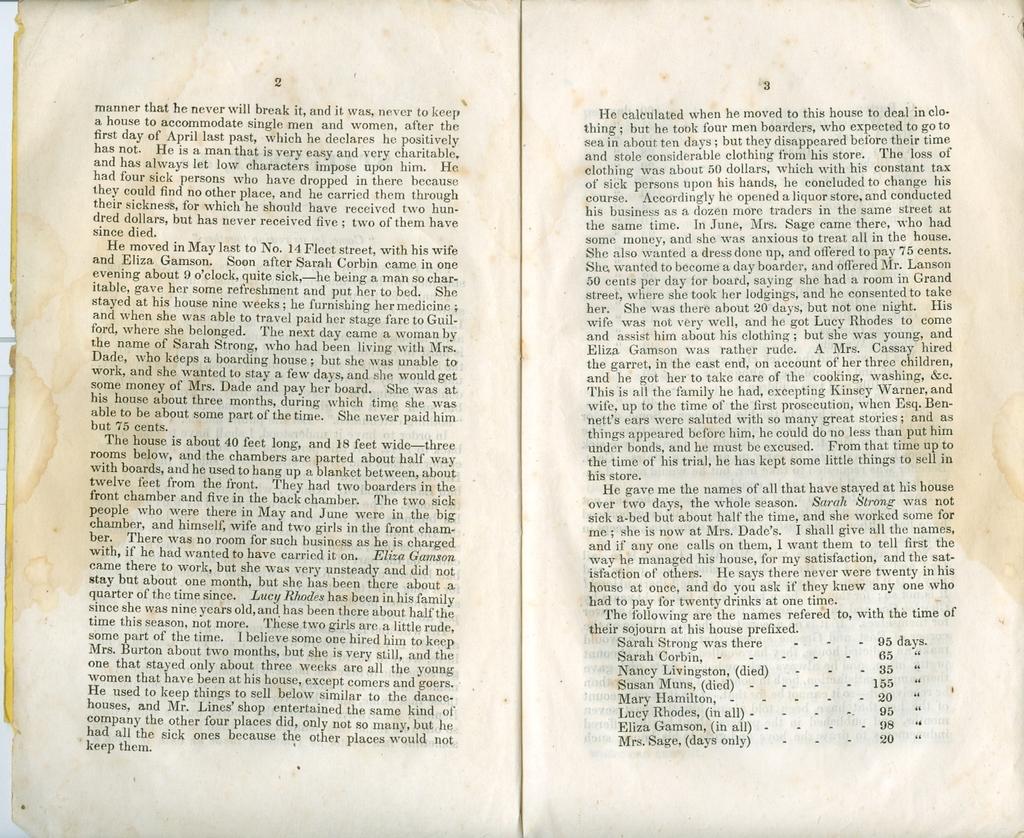What is the first word on the left page?
Ensure brevity in your answer.  Manner. 